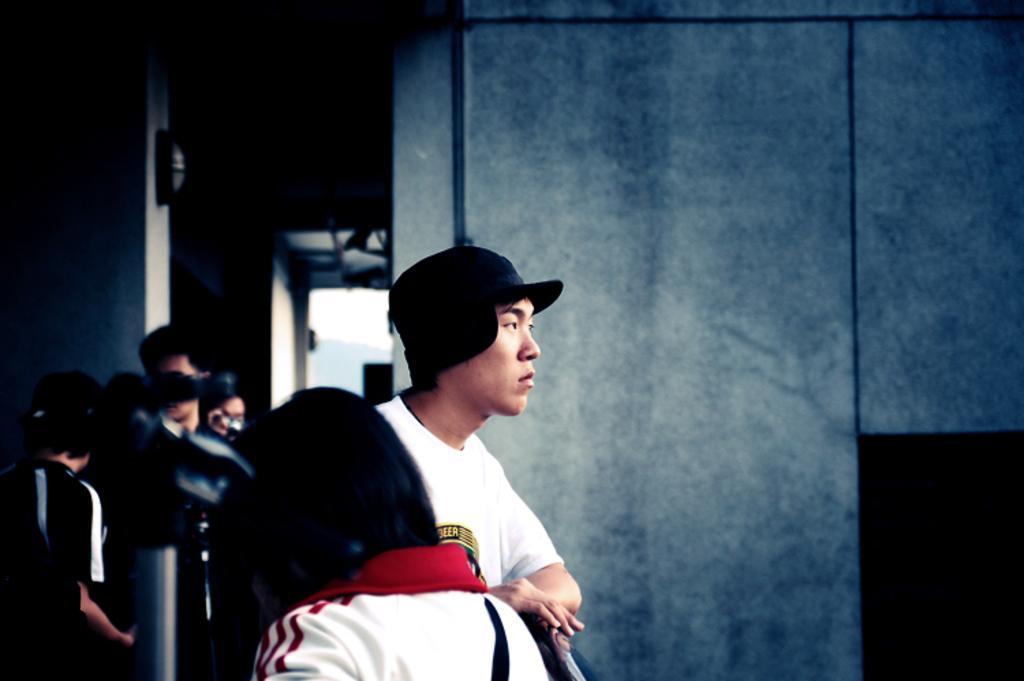Please provide a concise description of this image. In this image we can see the people and also the wall. We can also see a rod. 